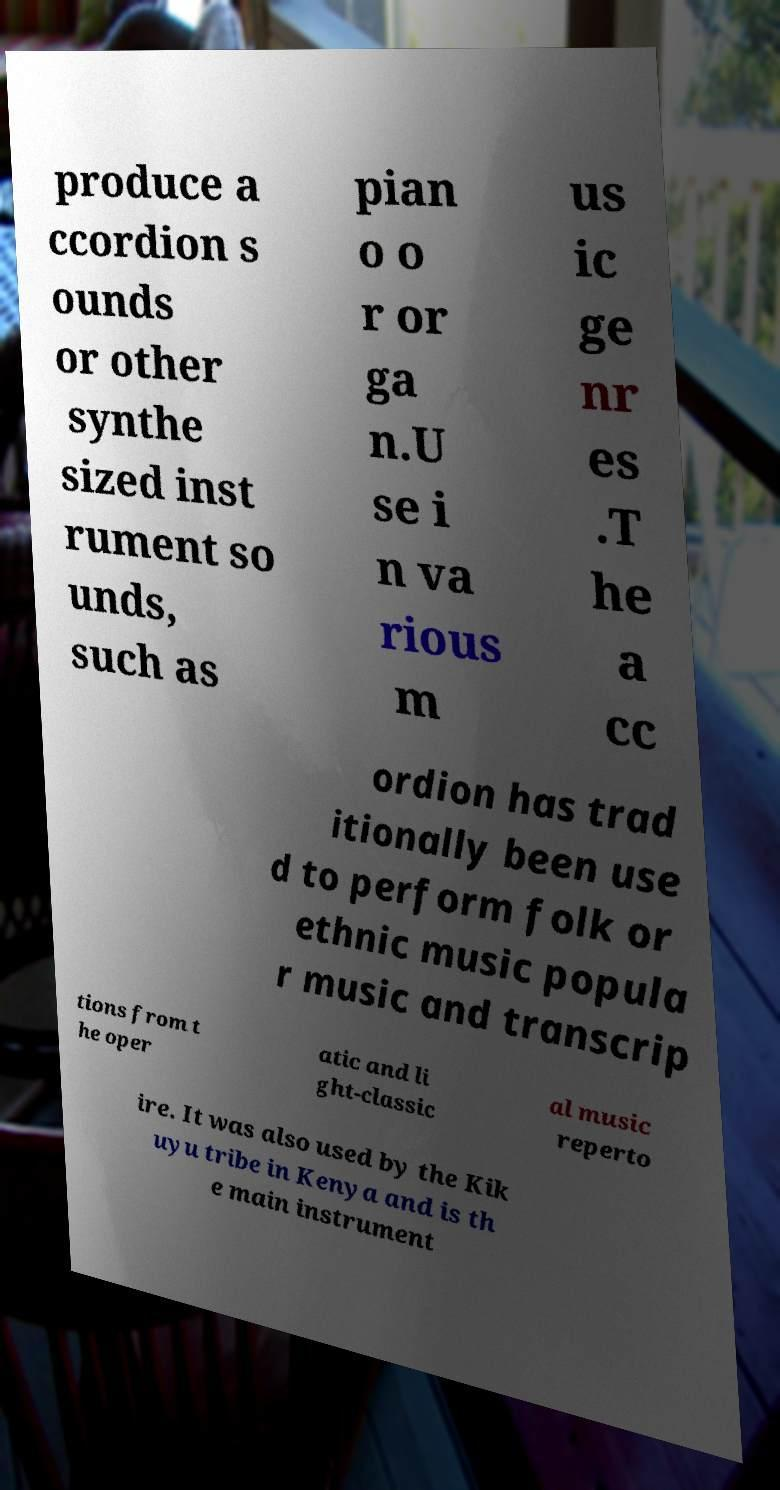Please read and relay the text visible in this image. What does it say? produce a ccordion s ounds or other synthe sized inst rument so unds, such as pian o o r or ga n.U se i n va rious m us ic ge nr es .T he a cc ordion has trad itionally been use d to perform folk or ethnic music popula r music and transcrip tions from t he oper atic and li ght-classic al music reperto ire. It was also used by the Kik uyu tribe in Kenya and is th e main instrument 